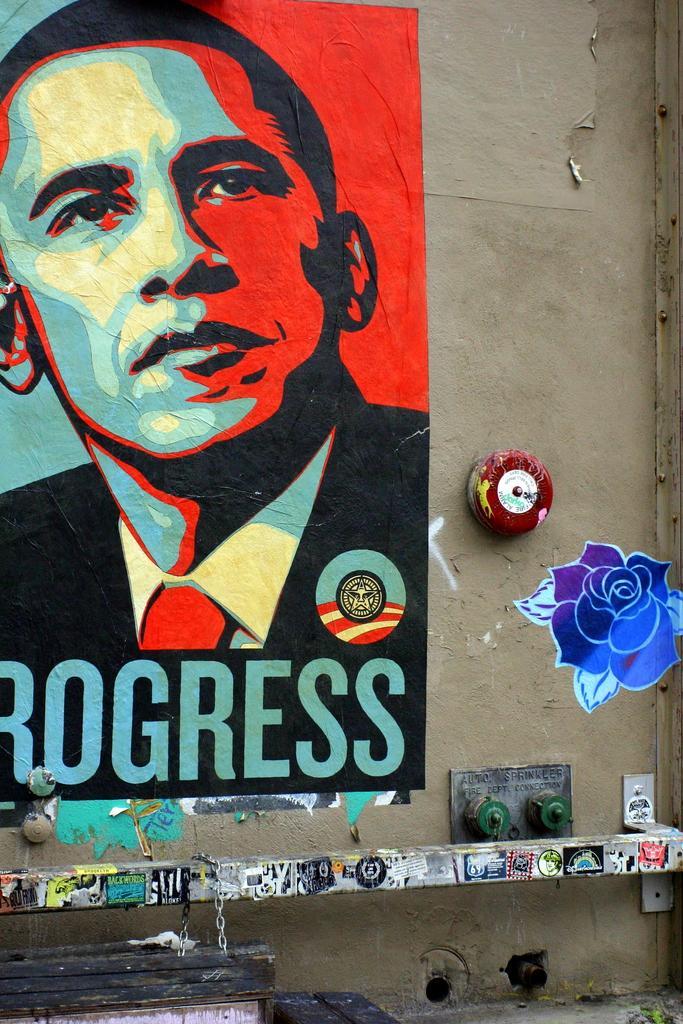Could you give a brief overview of what you see in this image? In this image we can see the picture of a person and a rose with some text on it which are painted on a wall. 